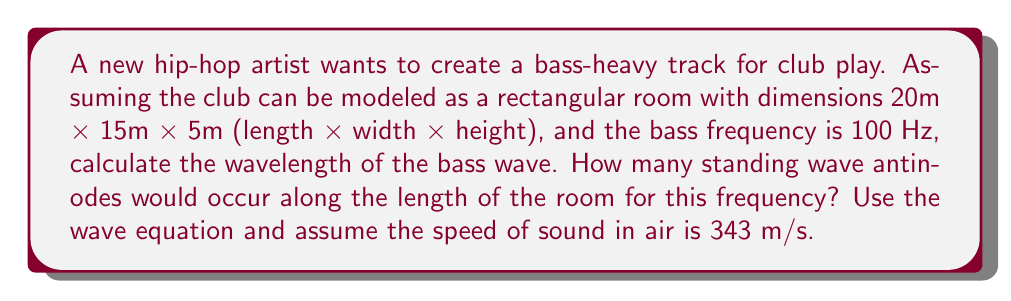Can you solve this math problem? To solve this problem, we'll follow these steps:

1) First, let's recall the wave equation for sound waves:

   $$f = \frac{v}{\lambda}$$

   Where $f$ is frequency, $v$ is wave speed, and $\lambda$ is wavelength.

2) We're given:
   - Frequency $f = 100$ Hz
   - Speed of sound $v = 343$ m/s

3) Rearranging the wave equation to solve for wavelength:

   $$\lambda = \frac{v}{f} = \frac{343 \text{ m/s}}{100 \text{ Hz}} = 3.43 \text{ m}$$

4) Now, to find the number of antinodes along the length of the room, we need to determine how many half-wavelengths fit in the room's length.

5) The room's length is 20 m. The distance between antinodes is half a wavelength. So:

   Number of antinodes = $\frac{\text{Room length}}{\text{Half wavelength}} = \frac{20 \text{ m}}{3.43 \text{ m}/2} = \frac{40}{3.43} \approx 11.66$

6) Since we can only have a whole number of antinodes, we round down to 11.

This means there would be 11 antinodes along the length of the room for a 100 Hz bass frequency.
Answer: Wavelength: 3.43 m; Number of antinodes: 11 